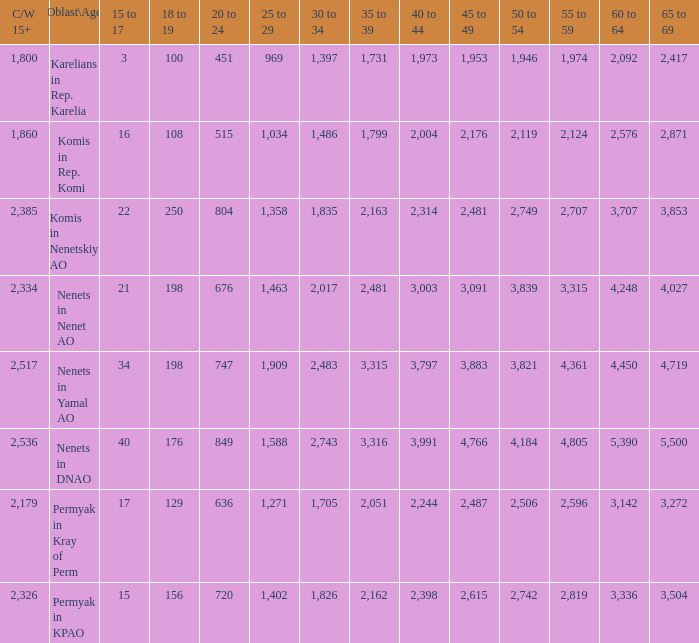What is the aggregate 30 to 34 when the 40 to 44 span is greater than 3,003, and the 50 to 54 span is beyond 4,184? None. 